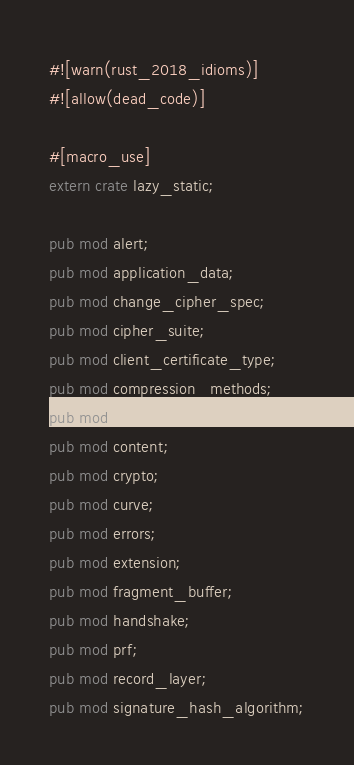Convert code to text. <code><loc_0><loc_0><loc_500><loc_500><_Rust_>#![warn(rust_2018_idioms)]
#![allow(dead_code)]

#[macro_use]
extern crate lazy_static;

pub mod alert;
pub mod application_data;
pub mod change_cipher_spec;
pub mod cipher_suite;
pub mod client_certificate_type;
pub mod compression_methods;
pub mod config;
pub mod content;
pub mod crypto;
pub mod curve;
pub mod errors;
pub mod extension;
pub mod fragment_buffer;
pub mod handshake;
pub mod prf;
pub mod record_layer;
pub mod signature_hash_algorithm;
</code> 